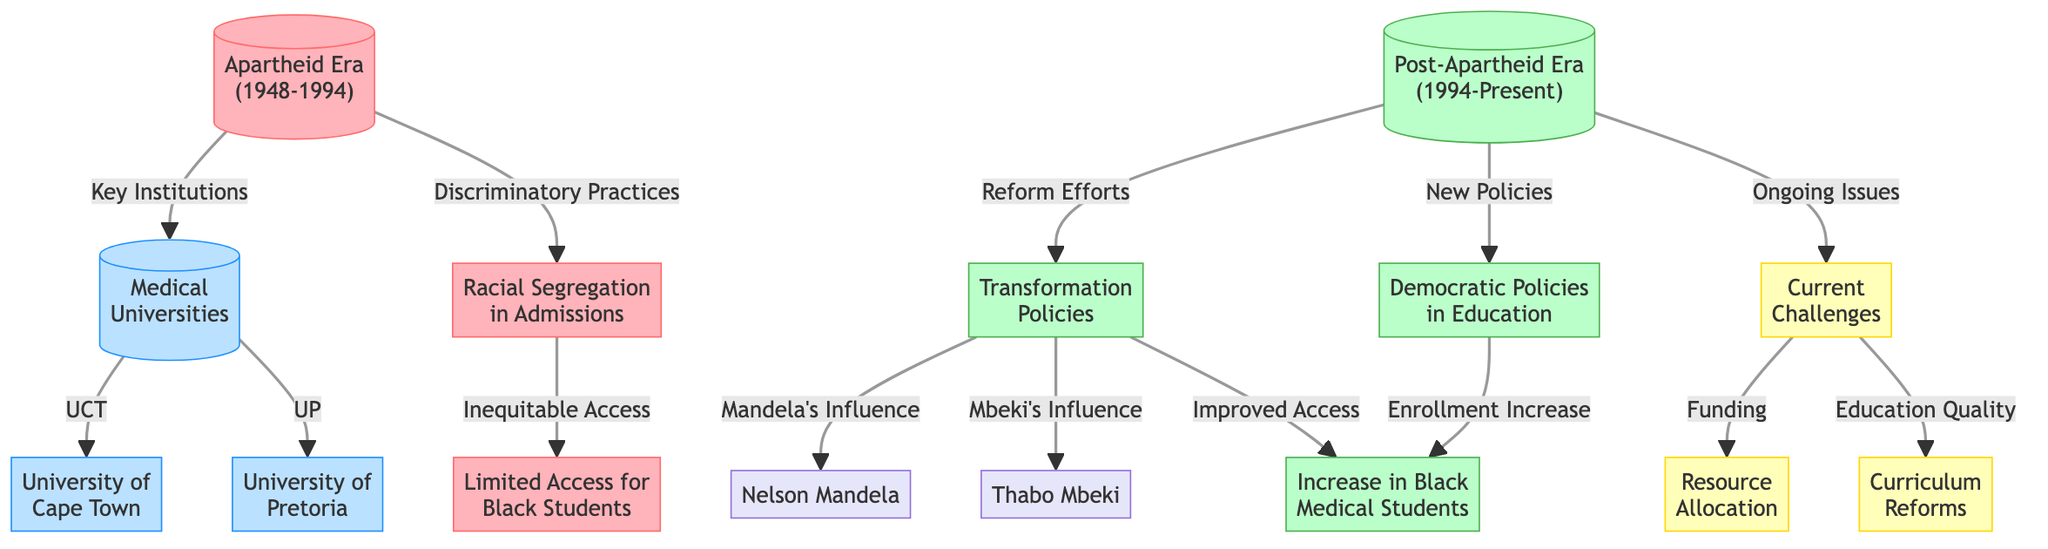What era does the diagram cover? The diagram explicitly states "Apartheid Era (1948-1994)" and "Post-Apartheid Era (1994-Present)" as its primary divisions. The years indicate the timeframes being referenced in the context of medical education.
Answer: Apartheid Era (1948-1994) and Post-Apartheid Era (1994-Present) How many medical universities are listed in the diagram? The diagram indicates two medical universities: University of Cape Town and University of Pretoria. Both are directly connected to the main node labeled "Medical Universities."
Answer: 2 What did Nelson Mandela influence according to the diagram? The diagram shows that Nelson Mandela influenced "Transformation Policies." This connection indicates his role in driving reforms in medical education during the post-apartheid era.
Answer: Transformation Policies What challenge is related to funding in the post-apartheid era? The diagram states that "Current Challenges" leads to "Funding," indicating that resource allocation for medical education remains a significant issue in the context of post-apartheid reforms.
Answer: Funding What policy was aimed at improving access to medical education? The diagram mentions "Democratic Policies in Education," which connects directly to the increase in enrollment of Black medical students, indicating these policies' purpose to improve access in the educational system.
Answer: Democratic Policies in Education What discriminatory practice was highlighted during the apartheid era? The flowchart connects "Apartheid Era" to "Discriminatory Practices," specifically mentioning "Racial Segregation in Admissions," which indicates this as a key issue limiting educational opportunities for certain groups.
Answer: Racial Segregation in Admissions What has been a persistent issue post-apartheid? The diagram links "Ongoing Issues" to "Current Challenges," which include "Resource Allocation" and "Curriculum Reforms," highlighting that both areas remain significant challenges in medical education today.
Answer: Current Challenges Which figure is associated with improved enrollment in medical education? The flowchart connects "Mandela's Influence" and "Mbeki's Influence" to "Increase in Black Medical Students," showcasing their contributions towards enhancing enrollment diversity during the post-apartheid era.
Answer: Mbeki's Influence What is the relationship between limited access for Black students and racial segregation? The diagram shows that "Limited Access for Black Students" flows from "Racial Segregation in Admissions," indicating that the segregationist policies directly resulted in restricted access to medical education for Black learners.
Answer: Limited Access for Black Students What two challenges are identified under "Current Challenges"? The diagram specifies "Funding" and "Education Quality" as two key challenges, indicating that these areas need attention in the ongoing efforts to improve medical education in South Africa post-apartheid.
Answer: Funding and Education Quality 